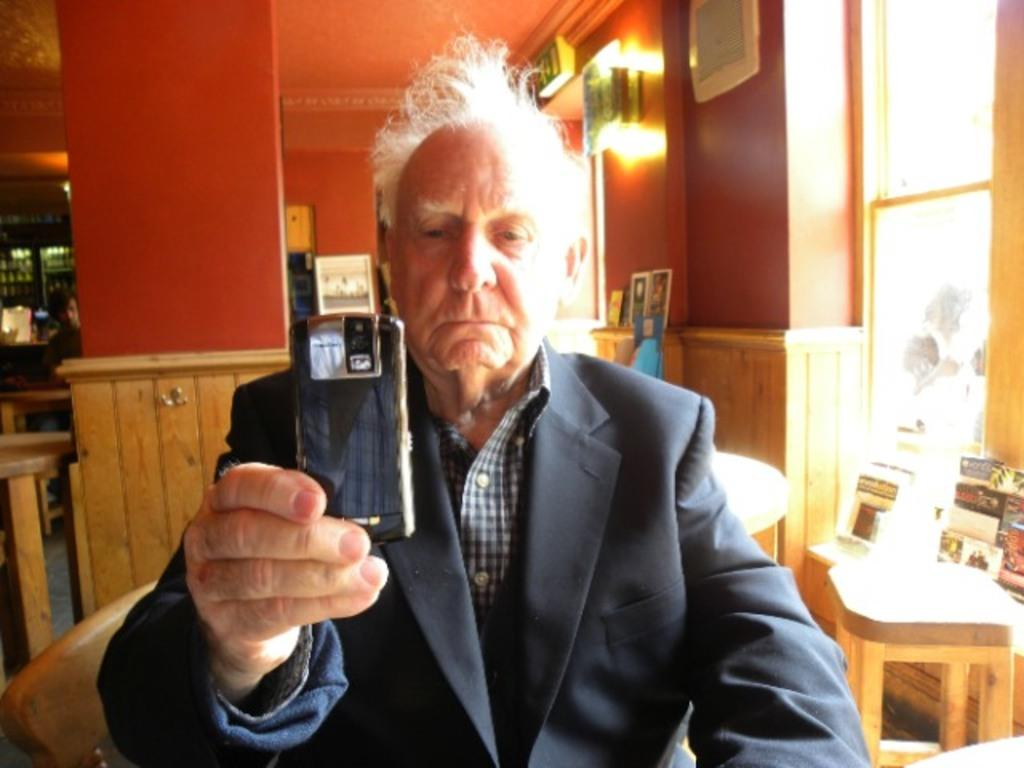What is the appearance of the man in the image? The man in the image is wearing a suit. What is the man holding in the image? The man is holding a mobile. Can you describe the background of the image? There is another person, tables, and a window in the background of the image. What type of kite is the man flying in the image? There is no kite present in the image; the man is holding a mobile. 